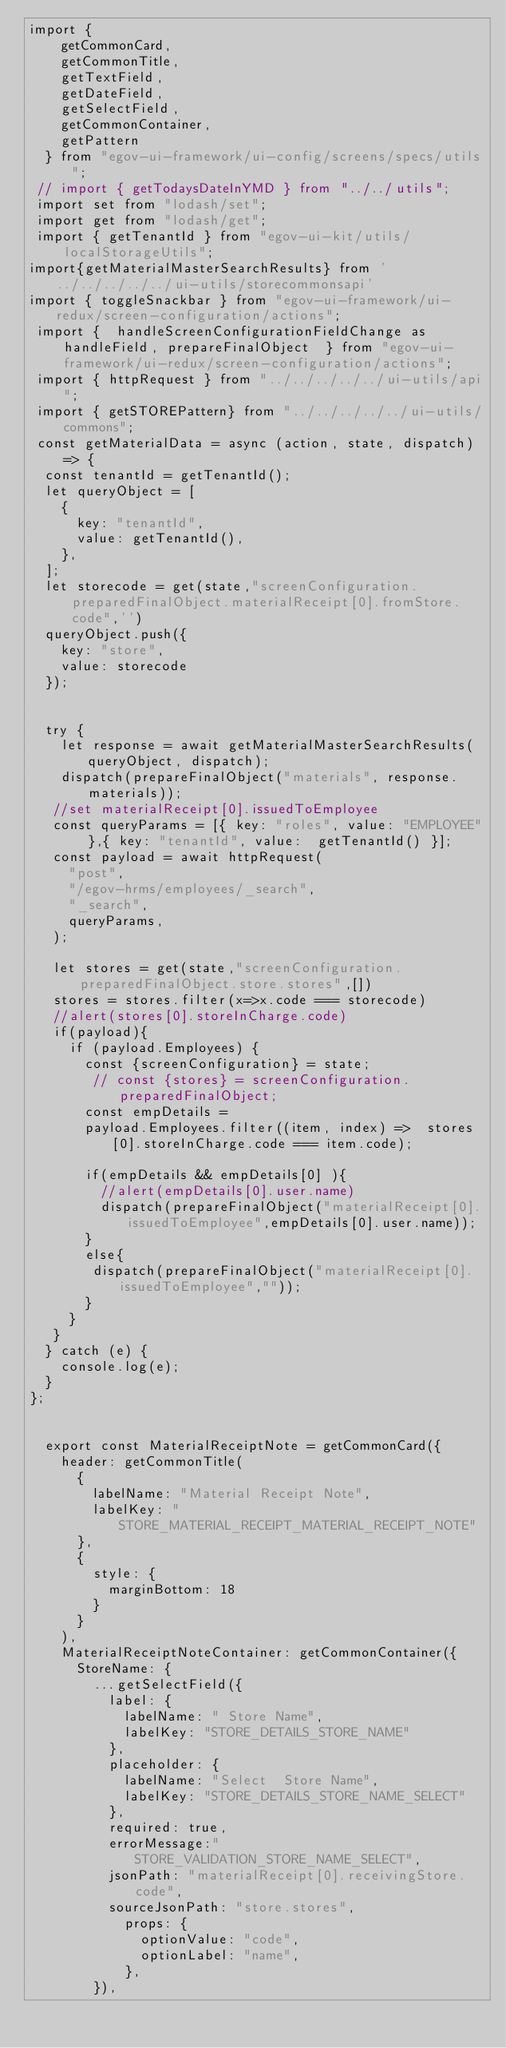<code> <loc_0><loc_0><loc_500><loc_500><_JavaScript_>import {
    getCommonCard,
    getCommonTitle,
    getTextField,
    getDateField,
    getSelectField,
    getCommonContainer,
    getPattern
  } from "egov-ui-framework/ui-config/screens/specs/utils";
 // import { getTodaysDateInYMD } from "../../utils";
 import set from "lodash/set";
 import get from "lodash/get";
 import { getTenantId } from "egov-ui-kit/utils/localStorageUtils";
import{getMaterialMasterSearchResults} from '../../../../../ui-utils/storecommonsapi'
import { toggleSnackbar } from "egov-ui-framework/ui-redux/screen-configuration/actions";
 import {  handleScreenConfigurationFieldChange as handleField, prepareFinalObject  } from "egov-ui-framework/ui-redux/screen-configuration/actions";
 import { httpRequest } from "../../../../../ui-utils/api";
 import { getSTOREPattern} from "../../../../../ui-utils/commons";
 const getMaterialData = async (action, state, dispatch) => {
  const tenantId = getTenantId();
  let queryObject = [
    {
      key: "tenantId",
      value: getTenantId(),
    },
  ];
  let storecode = get(state,"screenConfiguration.preparedFinalObject.materialReceipt[0].fromStore.code",'')
  queryObject.push({
    key: "store",
    value: storecode
  });

    
  try {
    let response = await getMaterialMasterSearchResults(queryObject, dispatch);
    dispatch(prepareFinalObject("materials", response.materials));
   //set materialReceipt[0].issuedToEmployee
   const queryParams = [{ key: "roles", value: "EMPLOYEE" },{ key: "tenantId", value:  getTenantId() }];
   const payload = await httpRequest(
     "post",
     "/egov-hrms/employees/_search",
     "_search",
     queryParams,
   );
  
   let stores = get(state,"screenConfiguration.preparedFinalObject.store.stores",[])
   stores = stores.filter(x=>x.code === storecode)
   //alert(stores[0].storeInCharge.code)
   if(payload){
     if (payload.Employees) {
       const {screenConfiguration} = state;
        // const {stores} = screenConfiguration.preparedFinalObject;
       const empDetails =
       payload.Employees.filter((item, index) =>  stores[0].storeInCharge.code === item.code);
     
       if(empDetails && empDetails[0] ){
         //alert(empDetails[0].user.name)        
         dispatch(prepareFinalObject("materialReceipt[0].issuedToEmployee",empDetails[0].user.name));  
       }
       else{
        dispatch(prepareFinalObject("materialReceipt[0].issuedToEmployee",""));  
       }
     }
   }
  } catch (e) {
    console.log(e);
  }
};


  export const MaterialReceiptNote = getCommonCard({
    header: getCommonTitle(
      {
        labelName: "Material Receipt Note",
        labelKey: "STORE_MATERIAL_RECEIPT_MATERIAL_RECEIPT_NOTE"
      },
      {
        style: {
          marginBottom: 18
        }
      }
    ),
    MaterialReceiptNoteContainer: getCommonContainer({
      StoreName: {
        ...getSelectField({
          label: {
            labelName: " Store Name",
            labelKey: "STORE_DETAILS_STORE_NAME"
          },
          placeholder: {
            labelName: "Select  Store Name",
            labelKey: "STORE_DETAILS_STORE_NAME_SELECT"
          },
          required: true,
          errorMessage:"STORE_VALIDATION_STORE_NAME_SELECT",
          jsonPath: "materialReceipt[0].receivingStore.code",
          sourceJsonPath: "store.stores",
            props: {
              optionValue: "code",
              optionLabel: "name",
            },
        }),</code> 